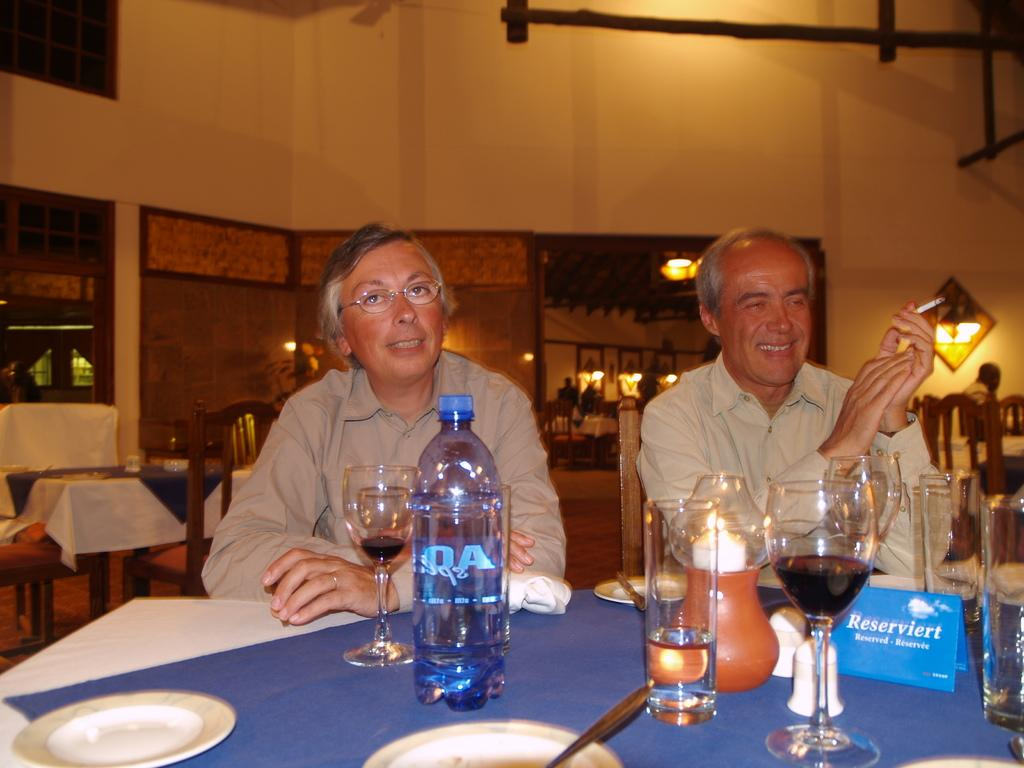How many people are in the image? There are two persons in the image. What are the persons doing in the image? The persons are sitting at a table. What objects can be seen on the table? There is a glass and a water bottle on the table. What is one person holding in their hand? One person is holding a cigarette in their hand. What type of range can be seen in the background of the image? There is no range visible in the image; it only features two persons sitting at a table with a glass, a water bottle, and a cigarette. What does the image smell like? The image does not have a smell, as it is a visual representation and not a physical object. 